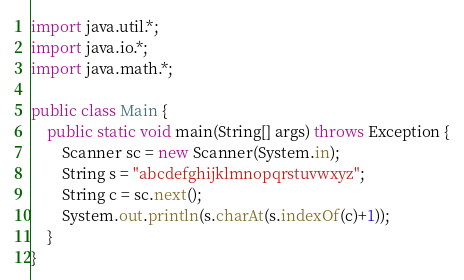<code> <loc_0><loc_0><loc_500><loc_500><_Java_>import java.util.*;
import java.io.*;
import java.math.*;
 
public class Main {
    public static void main(String[] args) throws Exception {
        Scanner sc = new Scanner(System.in);
        String s = "abcdefghijklmnopqrstuvwxyz";
        String c = sc.next();
        System.out.println(s.charAt(s.indexOf(c)+1));
    }
}</code> 